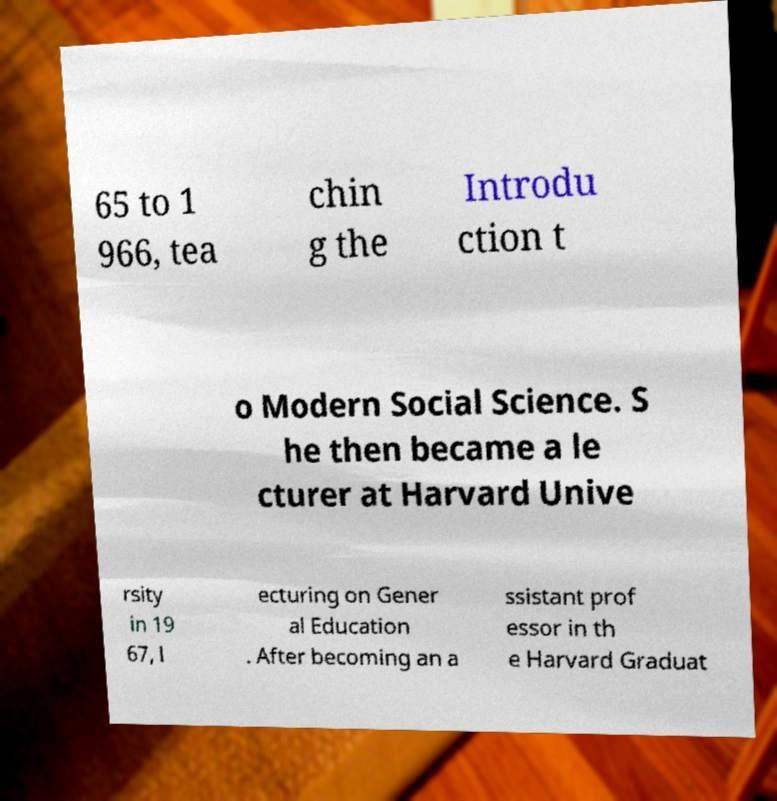Can you accurately transcribe the text from the provided image for me? 65 to 1 966, tea chin g the Introdu ction t o Modern Social Science. S he then became a le cturer at Harvard Unive rsity in 19 67, l ecturing on Gener al Education . After becoming an a ssistant prof essor in th e Harvard Graduat 